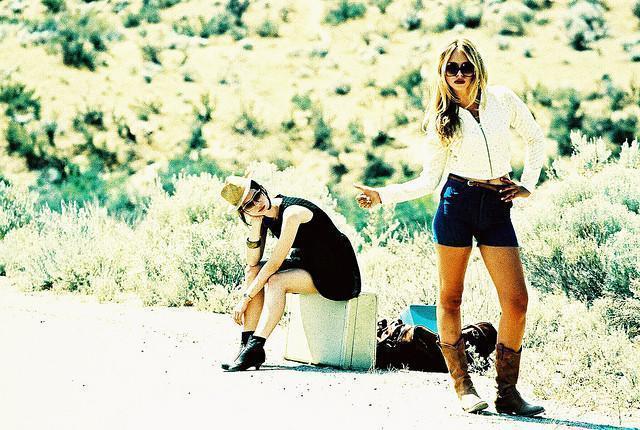What are the women doing on the road?
From the following four choices, select the correct answer to address the question.
Options: Waiting, sunbathing, posing, travelling. Posing. 